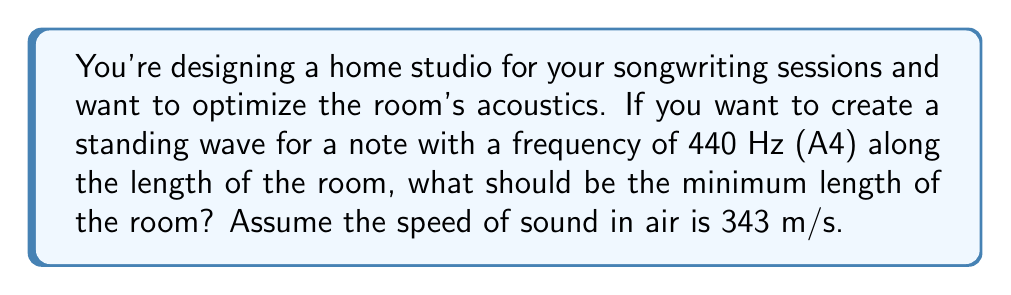Help me with this question. To solve this problem, we'll use the standing wave equation and the relationship between wavelength, frequency, and speed of sound.

Step 1: Recall the standing wave equation for the fundamental frequency (n=1):
$$ L = \frac{\lambda}{2} $$
Where L is the length of the room and λ is the wavelength.

Step 2: Use the wave equation to relate wavelength to frequency:
$$ v = f\lambda $$
Where v is the speed of sound, f is the frequency, and λ is the wavelength.

Step 3: Rearrange the wave equation to solve for λ:
$$ \lambda = \frac{v}{f} $$

Step 4: Substitute the given values:
$$ \lambda = \frac{343 \text{ m/s}}{440 \text{ Hz}} = 0.78 \text{ m} $$

Step 5: Use the standing wave equation to find the minimum room length:
$$ L = \frac{\lambda}{2} = \frac{0.78 \text{ m}}{2} = 0.39 \text{ m} $$

Therefore, the minimum length of the room should be 0.39 meters to create a standing wave for the A4 note (440 Hz).
Answer: 0.39 m 